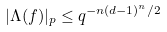<formula> <loc_0><loc_0><loc_500><loc_500>| \Lambda ( f ) | _ { p } \leq q ^ { - n ( d - 1 ) ^ { n } / 2 }</formula> 